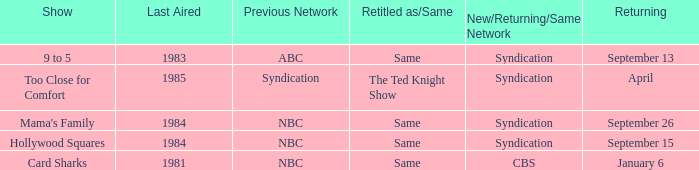Could you parse the entire table? {'header': ['Show', 'Last Aired', 'Previous Network', 'Retitled as/Same', 'New/Returning/Same Network', 'Returning'], 'rows': [['9 to 5', '1983', 'ABC', 'Same', 'Syndication', 'September 13'], ['Too Close for Comfort', '1985', 'Syndication', 'The Ted Knight Show', 'Syndication', 'April'], ["Mama's Family", '1984', 'NBC', 'Same', 'Syndication', 'September 26'], ['Hollywood Squares', '1984', 'NBC', 'Same', 'Syndication', 'September 15'], ['Card Sharks', '1981', 'NBC', 'Same', 'CBS', 'January 6']]} What was the earliest aired show that's returning on September 13? 1983.0. 